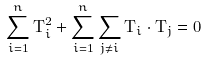<formula> <loc_0><loc_0><loc_500><loc_500>\sum _ { i = 1 } ^ { n } { \mathbf T } _ { i } ^ { 2 } + \sum _ { i = 1 } ^ { n } \sum _ { j \ne i } { \mathbf T } _ { i } \cdot { \mathbf T } _ { j } = 0</formula> 